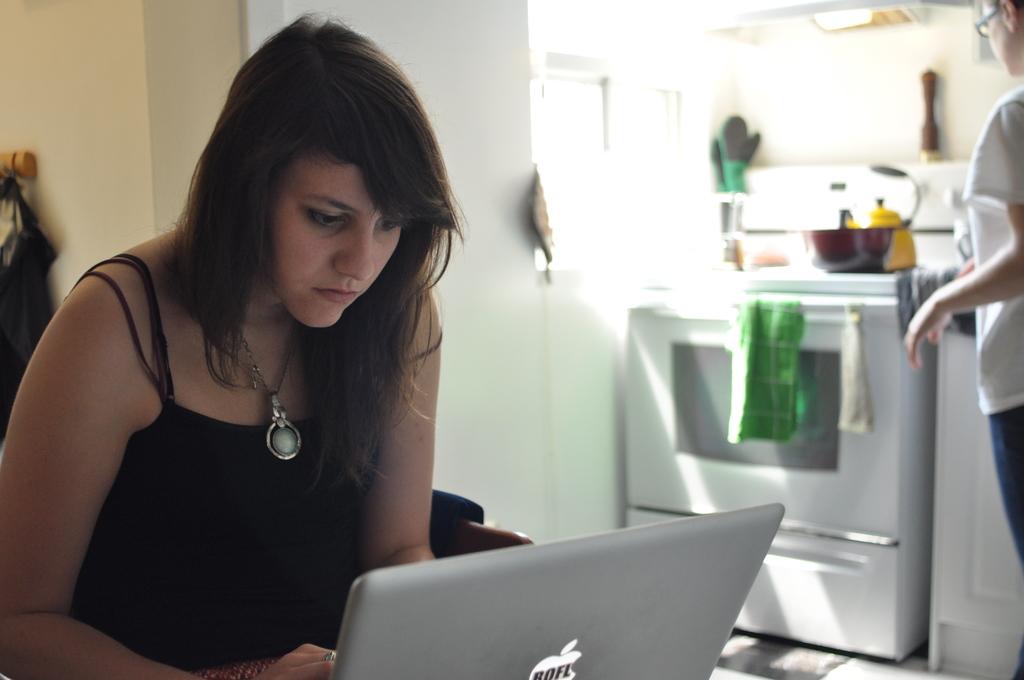What does the sticker on the laptop say?
Provide a short and direct response. Rofl. 